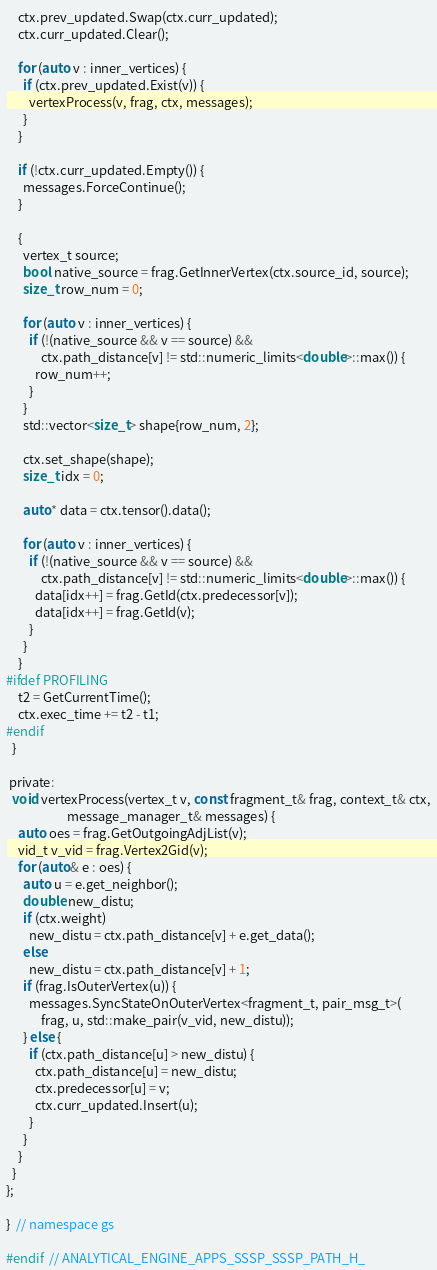Convert code to text. <code><loc_0><loc_0><loc_500><loc_500><_C_>    ctx.prev_updated.Swap(ctx.curr_updated);
    ctx.curr_updated.Clear();

    for (auto v : inner_vertices) {
      if (ctx.prev_updated.Exist(v)) {
        vertexProcess(v, frag, ctx, messages);
      }
    }

    if (!ctx.curr_updated.Empty()) {
      messages.ForceContinue();
    }

    {
      vertex_t source;
      bool native_source = frag.GetInnerVertex(ctx.source_id, source);
      size_t row_num = 0;

      for (auto v : inner_vertices) {
        if (!(native_source && v == source) &&
            ctx.path_distance[v] != std::numeric_limits<double>::max()) {
          row_num++;
        }
      }
      std::vector<size_t> shape{row_num, 2};

      ctx.set_shape(shape);
      size_t idx = 0;

      auto* data = ctx.tensor().data();

      for (auto v : inner_vertices) {
        if (!(native_source && v == source) &&
            ctx.path_distance[v] != std::numeric_limits<double>::max()) {
          data[idx++] = frag.GetId(ctx.predecessor[v]);
          data[idx++] = frag.GetId(v);
        }
      }
    }
#ifdef PROFILING
    t2 = GetCurrentTime();
    ctx.exec_time += t2 - t1;
#endif
  }

 private:
  void vertexProcess(vertex_t v, const fragment_t& frag, context_t& ctx,
                     message_manager_t& messages) {
    auto oes = frag.GetOutgoingAdjList(v);
    vid_t v_vid = frag.Vertex2Gid(v);
    for (auto& e : oes) {
      auto u = e.get_neighbor();
      double new_distu;
      if (ctx.weight)
        new_distu = ctx.path_distance[v] + e.get_data();
      else
        new_distu = ctx.path_distance[v] + 1;
      if (frag.IsOuterVertex(u)) {
        messages.SyncStateOnOuterVertex<fragment_t, pair_msg_t>(
            frag, u, std::make_pair(v_vid, new_distu));
      } else {
        if (ctx.path_distance[u] > new_distu) {
          ctx.path_distance[u] = new_distu;
          ctx.predecessor[u] = v;
          ctx.curr_updated.Insert(u);
        }
      }
    }
  }
};

}  // namespace gs

#endif  // ANALYTICAL_ENGINE_APPS_SSSP_SSSP_PATH_H_
</code> 